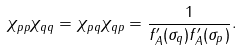<formula> <loc_0><loc_0><loc_500><loc_500>\chi _ { p p } \chi _ { q q } = \chi _ { p q } \chi _ { q p } = \frac { 1 } { f _ { A } ^ { \prime } ( \sigma _ { q } ) f _ { A } ^ { \prime } ( \sigma _ { p } ) } .</formula> 